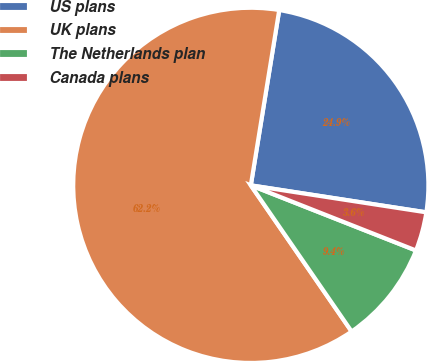<chart> <loc_0><loc_0><loc_500><loc_500><pie_chart><fcel>US plans<fcel>UK plans<fcel>The Netherlands plan<fcel>Canada plans<nl><fcel>24.87%<fcel>62.17%<fcel>9.41%<fcel>3.55%<nl></chart> 